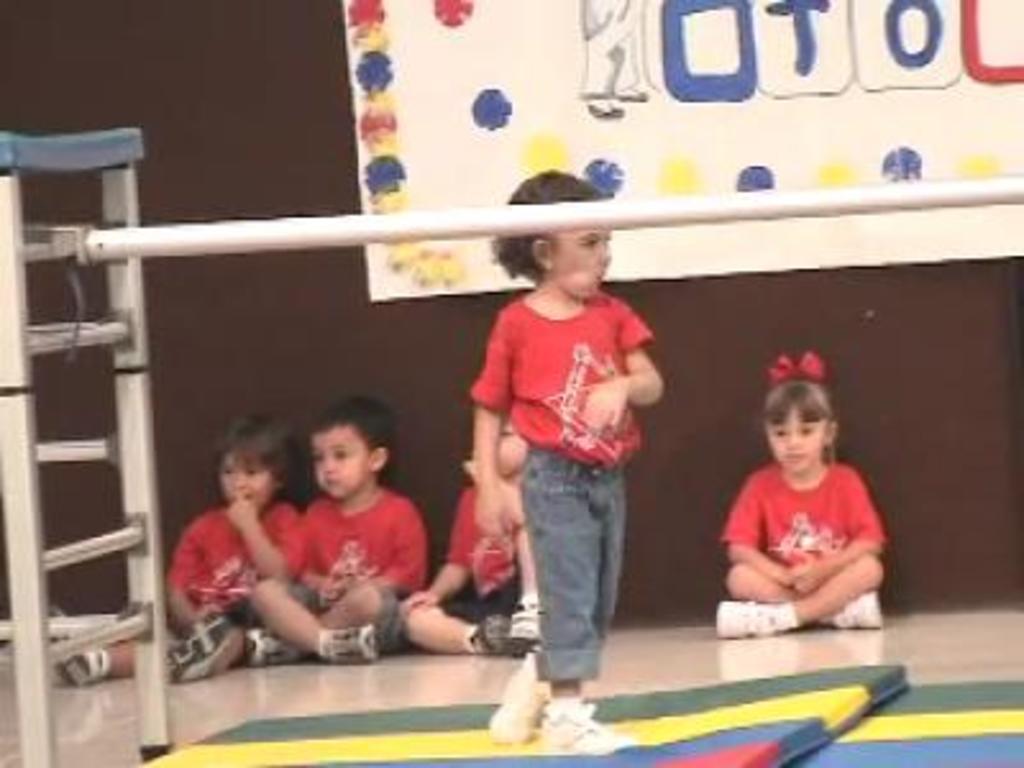Can you describe this image briefly? In this picture we can see few children, among them one girl is standing, behind we can see board. 